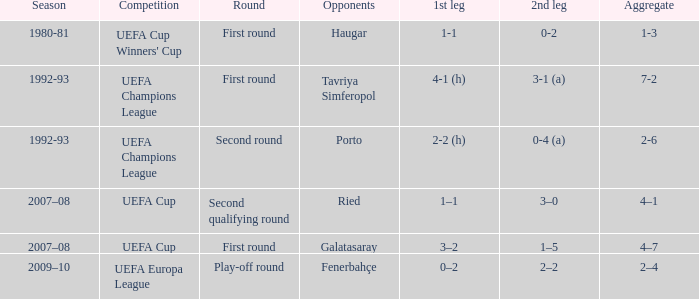What is the total number of 2nd leg where aggregate is 7-2 1.0. 